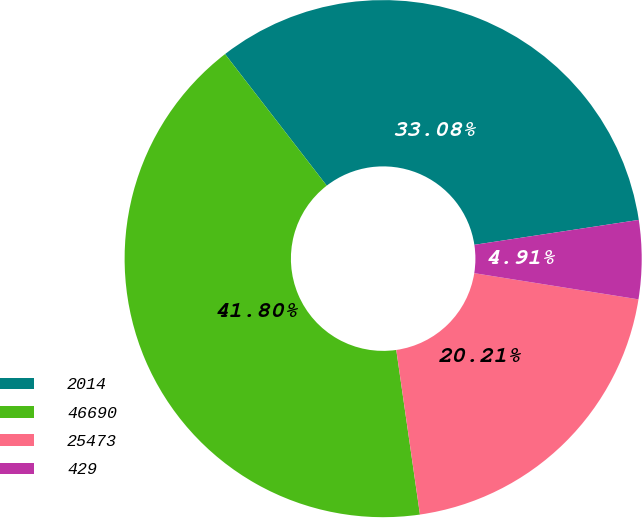Convert chart to OTSL. <chart><loc_0><loc_0><loc_500><loc_500><pie_chart><fcel>2014<fcel>46690<fcel>25473<fcel>429<nl><fcel>33.08%<fcel>41.8%<fcel>20.21%<fcel>4.91%<nl></chart> 